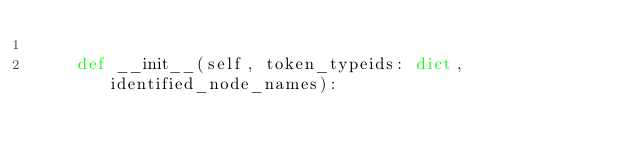<code> <loc_0><loc_0><loc_500><loc_500><_Python_>
    def __init__(self, token_typeids: dict, identified_node_names):</code> 